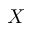Convert formula to latex. <formula><loc_0><loc_0><loc_500><loc_500>X</formula> 